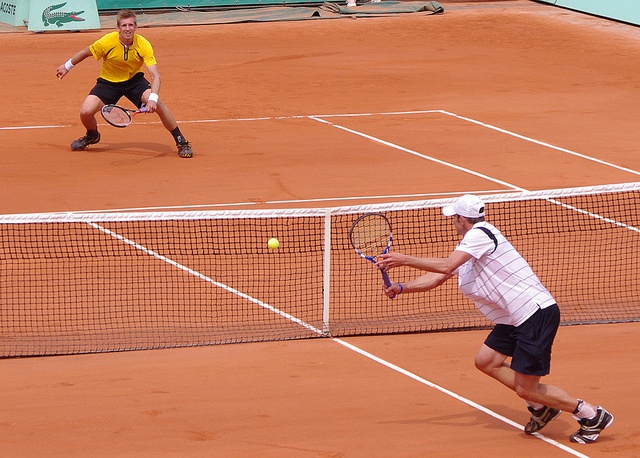Describe the objects in this image and their specific colors. I can see people in lightblue, lavender, black, brown, and lightpink tones, people in lightblue, black, red, orange, and brown tones, tennis racket in lightblue, salmon, brown, and maroon tones, tennis racket in lightblue, salmon, and brown tones, and sports ball in lightblue, khaki, lightyellow, and gold tones in this image. 